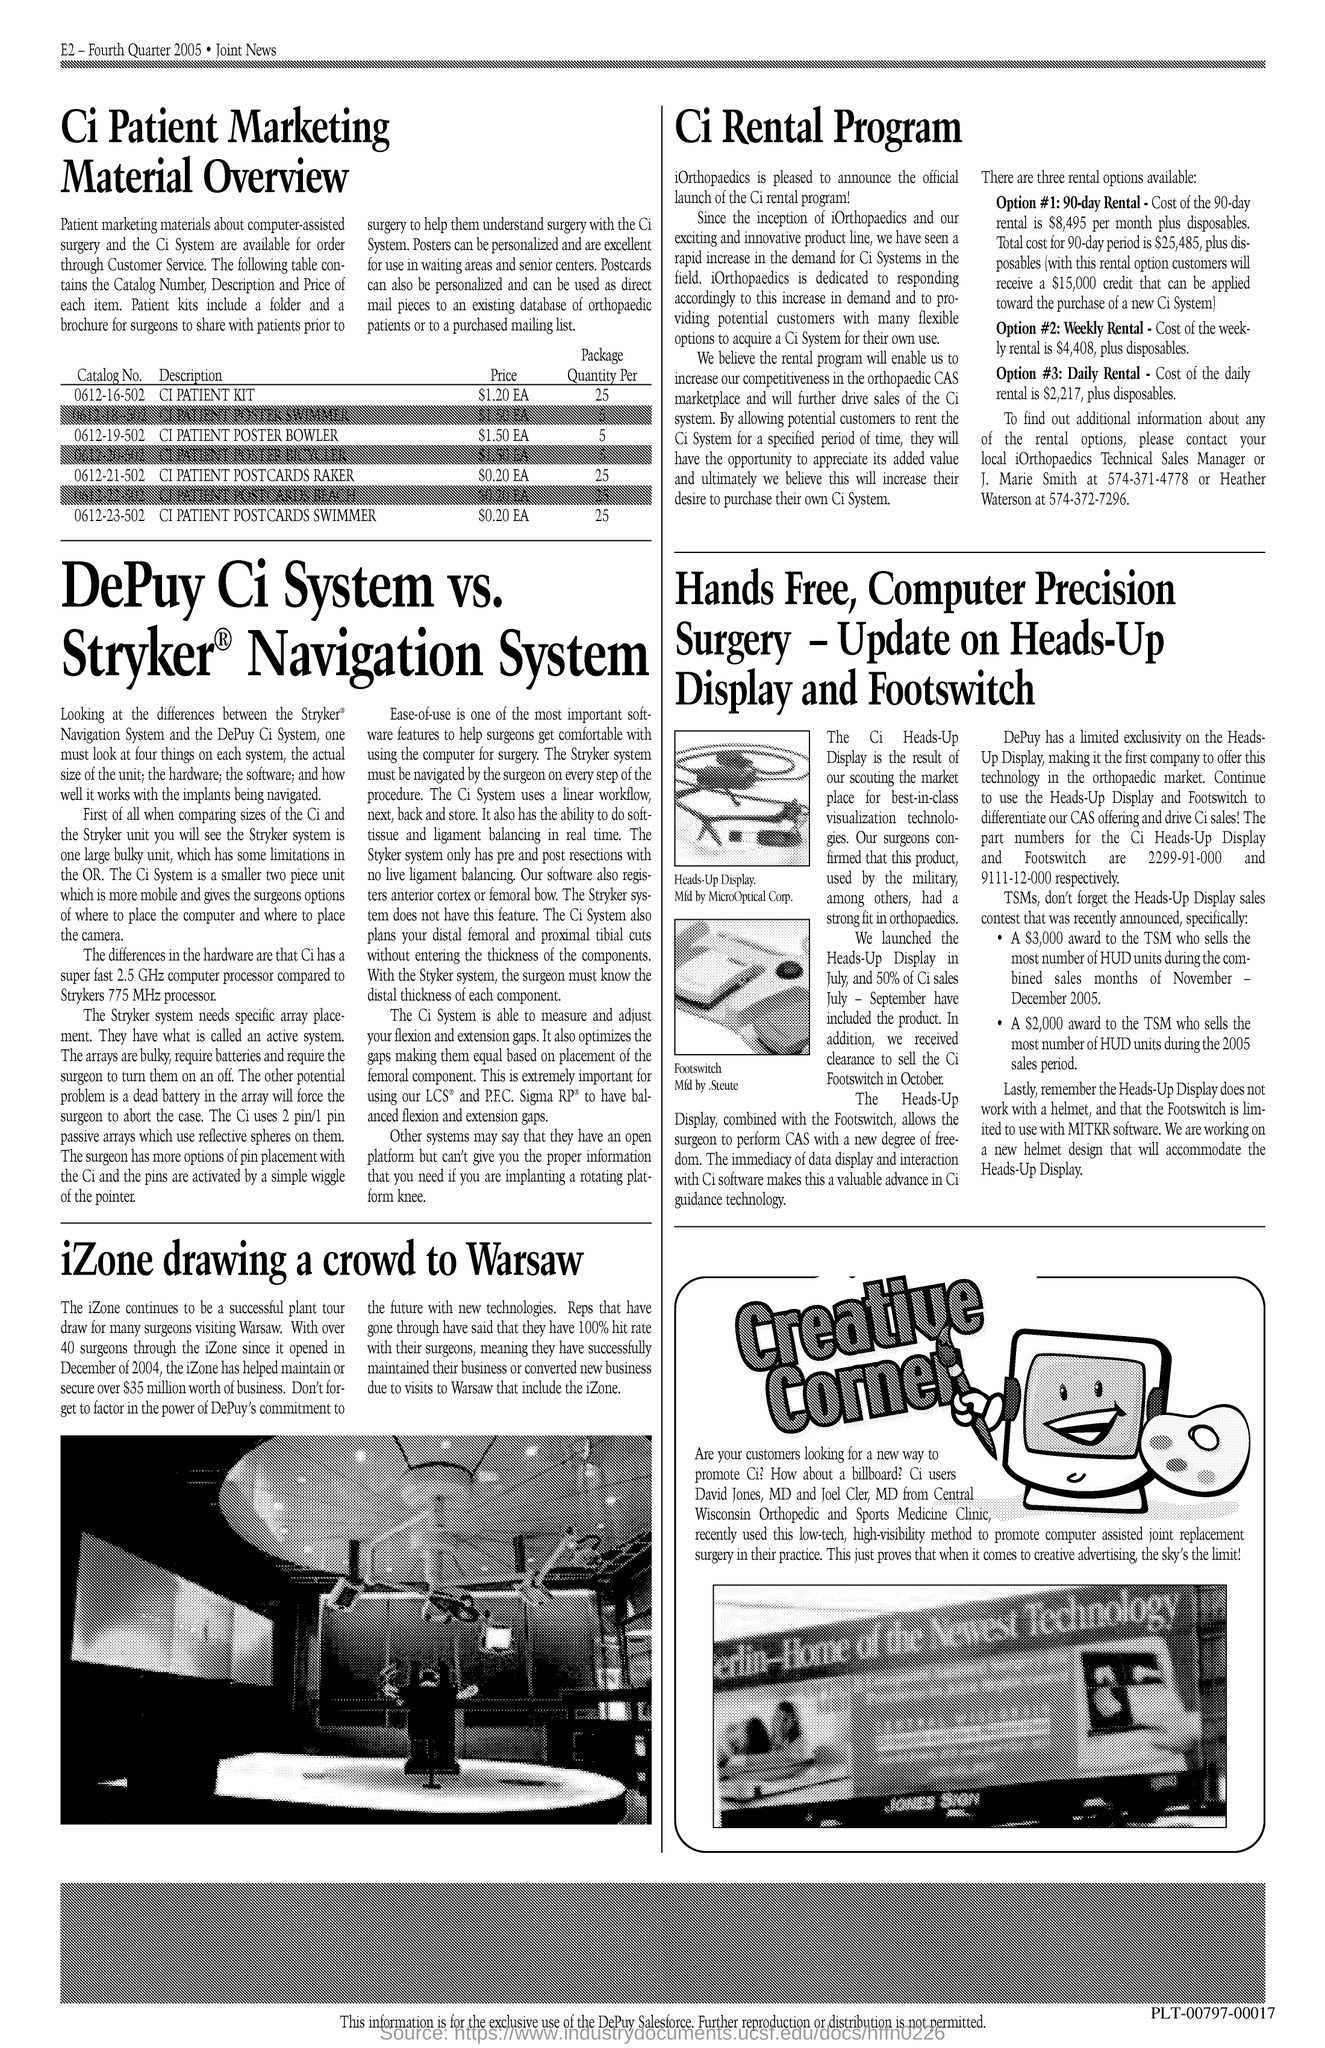Mention a couple of crucial points in this snapshot. Option number 2 is weekly rental. Option 3 is daily rental. Option number 1 is a 90-day rental agreement. 